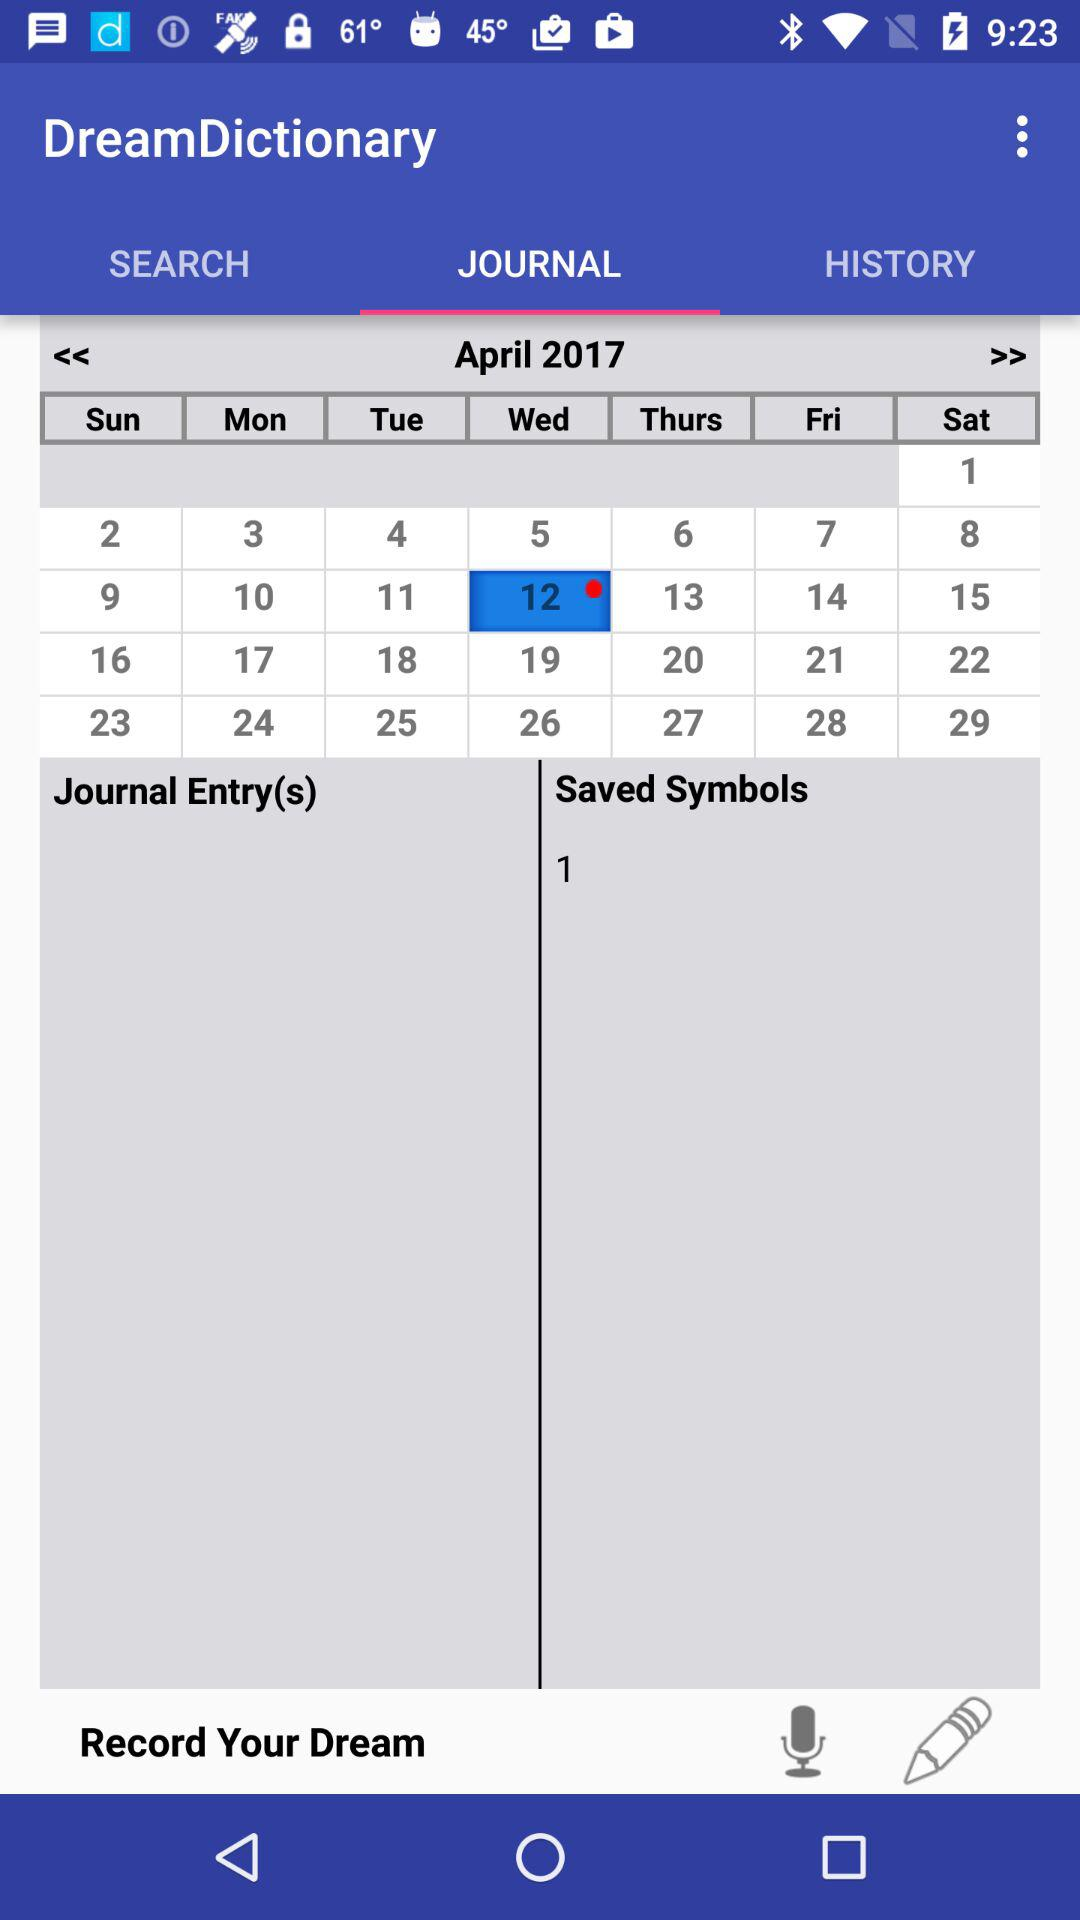What are the names of the different journal entries?
When the provided information is insufficient, respond with <no answer>. <no answer> 